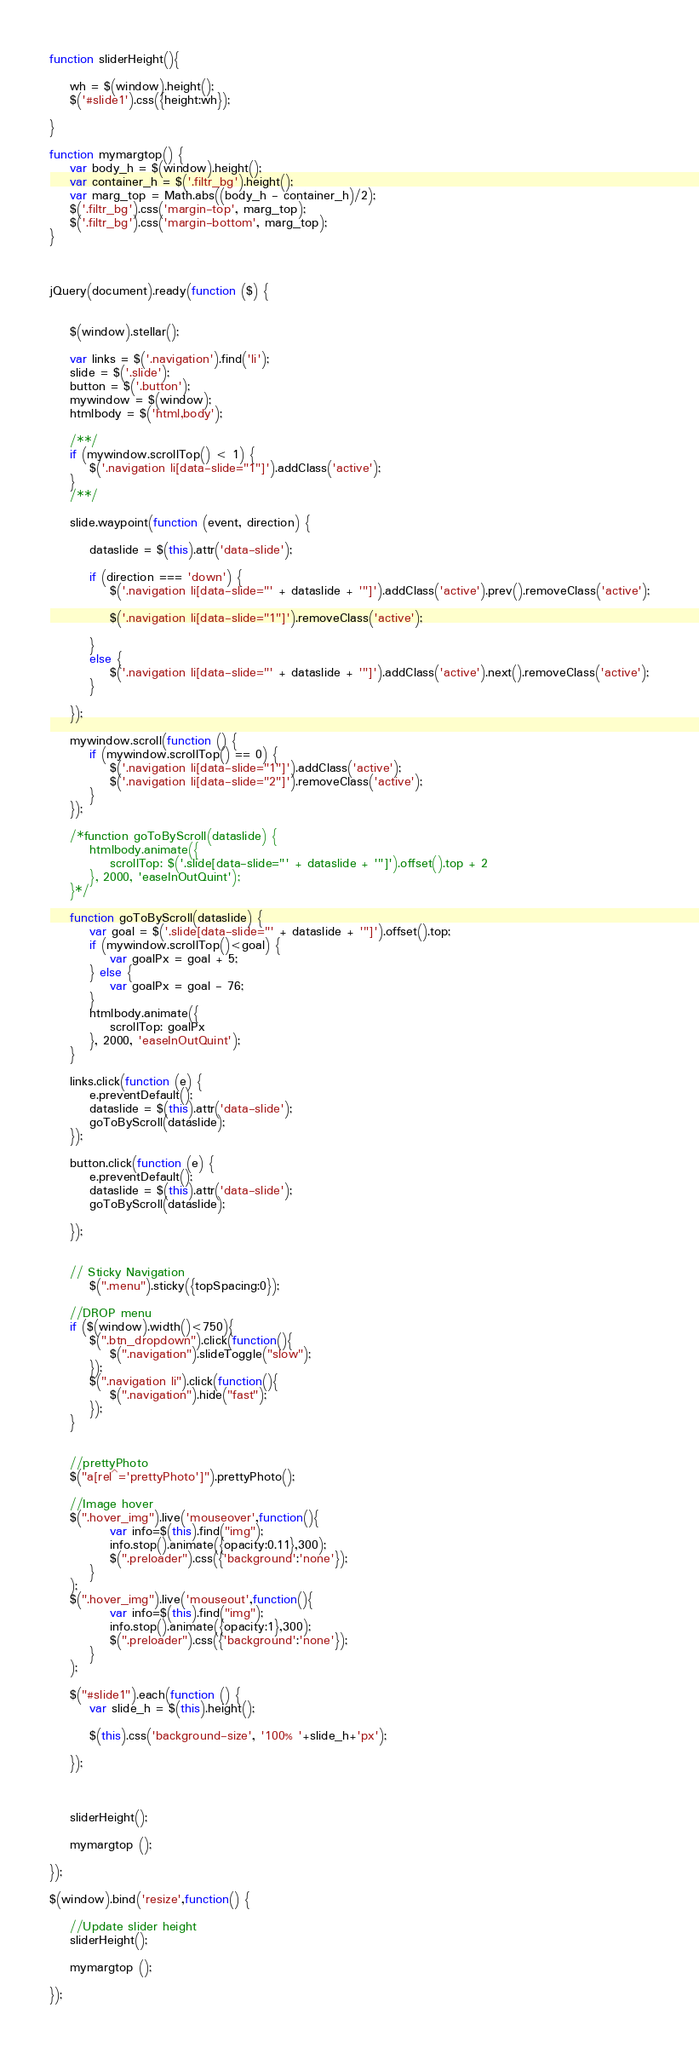Convert code to text. <code><loc_0><loc_0><loc_500><loc_500><_JavaScript_>function sliderHeight(){
		
	wh = $(window).height();
	$('#slide1').css({height:wh});
	
}

function mymargtop() {
	var body_h = $(window).height();
	var container_h = $('.filtr_bg').height();	
	var marg_top = Math.abs((body_h - container_h)/2);	
	$('.filtr_bg').css('margin-top', marg_top);
	$('.filtr_bg').css('margin-bottom', marg_top);
}



jQuery(document).ready(function ($) {


    $(window).stellar();

    var links = $('.navigation').find('li');
    slide = $('.slide');
    button = $('.button');
    mywindow = $(window);
    htmlbody = $('html,body');
	
	/**/	
	if (mywindow.scrollTop() < 1) {
		$('.navigation li[data-slide="1"]').addClass('active');
	}
	/**/

    slide.waypoint(function (event, direction) {

        dataslide = $(this).attr('data-slide');

        if (direction === 'down') {
            $('.navigation li[data-slide="' + dataslide + '"]').addClass('active').prev().removeClass('active');
			
			$('.navigation li[data-slide="1"]').removeClass('active');
			
        }
        else {
            $('.navigation li[data-slide="' + dataslide + '"]').addClass('active').next().removeClass('active');
        }

    });
 
    mywindow.scroll(function () {
        if (mywindow.scrollTop() == 0) {
            $('.navigation li[data-slide="1"]').addClass('active');
            $('.navigation li[data-slide="2"]').removeClass('active');
        }
    });

    /*function goToByScroll(dataslide) {
        htmlbody.animate({
            scrollTop: $('.slide[data-slide="' + dataslide + '"]').offset().top + 2
        }, 2000, 'easeInOutQuint');
    }*/
	
	function goToByScroll(dataslide) {
		var goal = $('.slide[data-slide="' + dataslide + '"]').offset().top;
		if (mywindow.scrollTop()<goal) {
			var goalPx = goal + 5;
		} else {
			var goalPx = goal - 76;
		}
        htmlbody.animate({
            scrollTop: goalPx
        }, 2000, 'easeInOutQuint');
    }

    links.click(function (e) {
        e.preventDefault();
        dataslide = $(this).attr('data-slide');
        goToByScroll(dataslide);
    });

    button.click(function (e) {
        e.preventDefault();
        dataslide = $(this).attr('data-slide');
        goToByScroll(dataslide);

    });
	
	
	// Sticky Navigation	
		$(".menu").sticky({topSpacing:0});
	
	//DROP menu	
	if ($(window).width()<750){
		$(".btn_dropdown").click(function(){
			$(".navigation").slideToggle("slow");
		});
		$(".navigation li").click(function(){
			$(".navigation").hide("fast");
		});
	}
	
	
	//prettyPhoto
	$("a[rel^='prettyPhoto']").prettyPhoto();
	
	//Image hover
	$(".hover_img").live('mouseover',function(){
			var info=$(this).find("img");
			info.stop().animate({opacity:0.11},300);
			$(".preloader").css({'background':'none'});
		}
	);
	$(".hover_img").live('mouseout',function(){
			var info=$(this).find("img");
			info.stop().animate({opacity:1},300);
			$(".preloader").css({'background':'none'});
		}
	);
	
	$("#slide1").each(function () {
        var slide_h = $(this).height();
		
		$(this).css('background-size', '100% '+slide_h+'px');
		
    });
	
	
	
	sliderHeight();
	
	mymargtop ();
	
});

$(window).bind('resize',function() {
		
	//Update slider height
	sliderHeight();
	
	mymargtop ();
	
});






</code> 